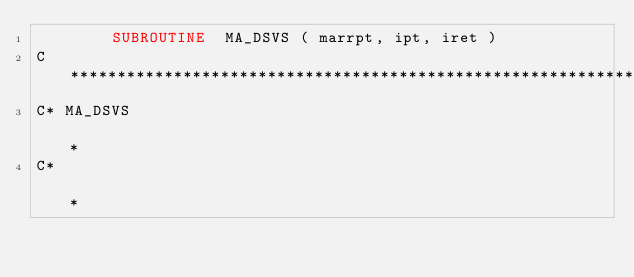Convert code to text. <code><loc_0><loc_0><loc_500><loc_500><_FORTRAN_>        SUBROUTINE  MA_DSVS ( marrpt, ipt, iret )
C************************************************************************
C* MA_DSVS                                                              *
C*                                                                      *</code> 